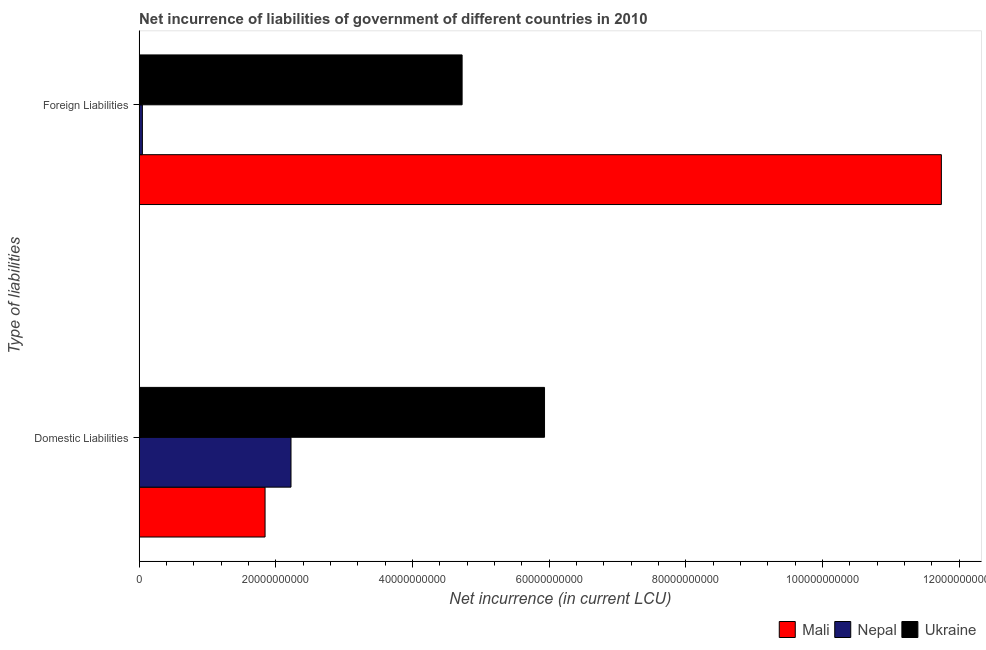How many groups of bars are there?
Give a very brief answer. 2. Are the number of bars on each tick of the Y-axis equal?
Your answer should be very brief. Yes. How many bars are there on the 2nd tick from the bottom?
Give a very brief answer. 3. What is the label of the 1st group of bars from the top?
Your response must be concise. Foreign Liabilities. What is the net incurrence of domestic liabilities in Ukraine?
Provide a short and direct response. 5.93e+1. Across all countries, what is the maximum net incurrence of foreign liabilities?
Give a very brief answer. 1.17e+11. Across all countries, what is the minimum net incurrence of domestic liabilities?
Make the answer very short. 1.84e+1. In which country was the net incurrence of domestic liabilities maximum?
Offer a terse response. Ukraine. In which country was the net incurrence of domestic liabilities minimum?
Your answer should be very brief. Mali. What is the total net incurrence of domestic liabilities in the graph?
Give a very brief answer. 1.00e+11. What is the difference between the net incurrence of domestic liabilities in Mali and that in Ukraine?
Ensure brevity in your answer.  -4.09e+1. What is the difference between the net incurrence of domestic liabilities in Nepal and the net incurrence of foreign liabilities in Mali?
Your answer should be compact. -9.52e+1. What is the average net incurrence of foreign liabilities per country?
Provide a succinct answer. 5.50e+1. What is the difference between the net incurrence of domestic liabilities and net incurrence of foreign liabilities in Ukraine?
Offer a very short reply. 1.21e+1. What is the ratio of the net incurrence of domestic liabilities in Nepal to that in Mali?
Offer a very short reply. 1.21. What does the 1st bar from the top in Domestic Liabilities represents?
Your answer should be very brief. Ukraine. What does the 3rd bar from the bottom in Domestic Liabilities represents?
Your answer should be very brief. Ukraine. How many bars are there?
Provide a short and direct response. 6. How many countries are there in the graph?
Provide a succinct answer. 3. Does the graph contain any zero values?
Offer a terse response. No. Does the graph contain grids?
Your response must be concise. No. Where does the legend appear in the graph?
Make the answer very short. Bottom right. How are the legend labels stacked?
Provide a succinct answer. Horizontal. What is the title of the graph?
Offer a very short reply. Net incurrence of liabilities of government of different countries in 2010. Does "Qatar" appear as one of the legend labels in the graph?
Offer a very short reply. No. What is the label or title of the X-axis?
Make the answer very short. Net incurrence (in current LCU). What is the label or title of the Y-axis?
Provide a succinct answer. Type of liabilities. What is the Net incurrence (in current LCU) in Mali in Domestic Liabilities?
Provide a short and direct response. 1.84e+1. What is the Net incurrence (in current LCU) in Nepal in Domestic Liabilities?
Offer a terse response. 2.22e+1. What is the Net incurrence (in current LCU) of Ukraine in Domestic Liabilities?
Provide a succinct answer. 5.93e+1. What is the Net incurrence (in current LCU) of Mali in Foreign Liabilities?
Offer a terse response. 1.17e+11. What is the Net incurrence (in current LCU) in Nepal in Foreign Liabilities?
Give a very brief answer. 4.80e+08. What is the Net incurrence (in current LCU) of Ukraine in Foreign Liabilities?
Offer a very short reply. 4.73e+1. Across all Type of liabilities, what is the maximum Net incurrence (in current LCU) of Mali?
Make the answer very short. 1.17e+11. Across all Type of liabilities, what is the maximum Net incurrence (in current LCU) in Nepal?
Give a very brief answer. 2.22e+1. Across all Type of liabilities, what is the maximum Net incurrence (in current LCU) of Ukraine?
Make the answer very short. 5.93e+1. Across all Type of liabilities, what is the minimum Net incurrence (in current LCU) of Mali?
Offer a terse response. 1.84e+1. Across all Type of liabilities, what is the minimum Net incurrence (in current LCU) in Nepal?
Provide a succinct answer. 4.80e+08. Across all Type of liabilities, what is the minimum Net incurrence (in current LCU) in Ukraine?
Your response must be concise. 4.73e+1. What is the total Net incurrence (in current LCU) in Mali in the graph?
Your answer should be compact. 1.36e+11. What is the total Net incurrence (in current LCU) in Nepal in the graph?
Provide a succinct answer. 2.27e+1. What is the total Net incurrence (in current LCU) in Ukraine in the graph?
Give a very brief answer. 1.07e+11. What is the difference between the Net incurrence (in current LCU) in Mali in Domestic Liabilities and that in Foreign Liabilities?
Offer a terse response. -9.89e+1. What is the difference between the Net incurrence (in current LCU) of Nepal in Domestic Liabilities and that in Foreign Liabilities?
Keep it short and to the point. 2.17e+1. What is the difference between the Net incurrence (in current LCU) of Ukraine in Domestic Liabilities and that in Foreign Liabilities?
Offer a terse response. 1.21e+1. What is the difference between the Net incurrence (in current LCU) of Mali in Domestic Liabilities and the Net incurrence (in current LCU) of Nepal in Foreign Liabilities?
Ensure brevity in your answer.  1.79e+1. What is the difference between the Net incurrence (in current LCU) in Mali in Domestic Liabilities and the Net incurrence (in current LCU) in Ukraine in Foreign Liabilities?
Keep it short and to the point. -2.88e+1. What is the difference between the Net incurrence (in current LCU) of Nepal in Domestic Liabilities and the Net incurrence (in current LCU) of Ukraine in Foreign Liabilities?
Your response must be concise. -2.50e+1. What is the average Net incurrence (in current LCU) in Mali per Type of liabilities?
Provide a short and direct response. 6.79e+1. What is the average Net incurrence (in current LCU) in Nepal per Type of liabilities?
Provide a succinct answer. 1.14e+1. What is the average Net incurrence (in current LCU) in Ukraine per Type of liabilities?
Provide a succinct answer. 5.33e+1. What is the difference between the Net incurrence (in current LCU) in Mali and Net incurrence (in current LCU) in Nepal in Domestic Liabilities?
Your answer should be compact. -3.79e+09. What is the difference between the Net incurrence (in current LCU) in Mali and Net incurrence (in current LCU) in Ukraine in Domestic Liabilities?
Your answer should be compact. -4.09e+1. What is the difference between the Net incurrence (in current LCU) of Nepal and Net incurrence (in current LCU) of Ukraine in Domestic Liabilities?
Offer a very short reply. -3.71e+1. What is the difference between the Net incurrence (in current LCU) of Mali and Net incurrence (in current LCU) of Nepal in Foreign Liabilities?
Offer a very short reply. 1.17e+11. What is the difference between the Net incurrence (in current LCU) in Mali and Net incurrence (in current LCU) in Ukraine in Foreign Liabilities?
Your answer should be very brief. 7.01e+1. What is the difference between the Net incurrence (in current LCU) of Nepal and Net incurrence (in current LCU) of Ukraine in Foreign Liabilities?
Provide a short and direct response. -4.68e+1. What is the ratio of the Net incurrence (in current LCU) of Mali in Domestic Liabilities to that in Foreign Liabilities?
Keep it short and to the point. 0.16. What is the ratio of the Net incurrence (in current LCU) in Nepal in Domestic Liabilities to that in Foreign Liabilities?
Offer a terse response. 46.27. What is the ratio of the Net incurrence (in current LCU) in Ukraine in Domestic Liabilities to that in Foreign Liabilities?
Provide a short and direct response. 1.26. What is the difference between the highest and the second highest Net incurrence (in current LCU) of Mali?
Your response must be concise. 9.89e+1. What is the difference between the highest and the second highest Net incurrence (in current LCU) of Nepal?
Keep it short and to the point. 2.17e+1. What is the difference between the highest and the second highest Net incurrence (in current LCU) of Ukraine?
Ensure brevity in your answer.  1.21e+1. What is the difference between the highest and the lowest Net incurrence (in current LCU) of Mali?
Offer a terse response. 9.89e+1. What is the difference between the highest and the lowest Net incurrence (in current LCU) in Nepal?
Offer a very short reply. 2.17e+1. What is the difference between the highest and the lowest Net incurrence (in current LCU) of Ukraine?
Provide a succinct answer. 1.21e+1. 